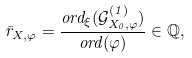Convert formula to latex. <formula><loc_0><loc_0><loc_500><loc_500>\bar { r } _ { X , \varphi } = \frac { o r d _ { \xi } ( \mathcal { G } _ { X _ { 0 } , \varphi } ^ { ( 1 ) } ) } { o r d ( \varphi ) } \in \mathbb { Q } ,</formula> 